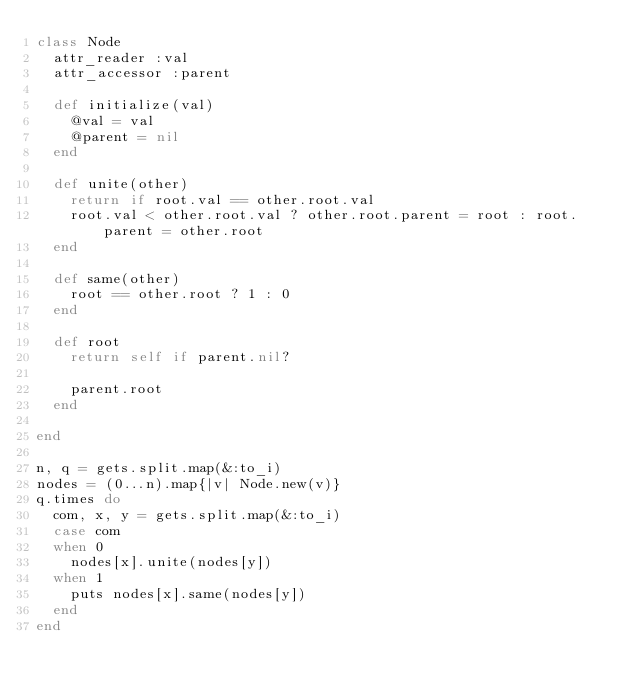<code> <loc_0><loc_0><loc_500><loc_500><_Ruby_>class Node
  attr_reader :val
  attr_accessor :parent

  def initialize(val)
    @val = val
    @parent = nil
  end

  def unite(other)
    return if root.val == other.root.val
    root.val < other.root.val ? other.root.parent = root : root.parent = other.root
  end

  def same(other)
    root == other.root ? 1 : 0
  end

  def root
    return self if parent.nil?

    parent.root
  end
 
end

n, q = gets.split.map(&:to_i)
nodes = (0...n).map{|v| Node.new(v)}
q.times do
  com, x, y = gets.split.map(&:to_i)
  case com
  when 0
    nodes[x].unite(nodes[y])
  when 1
    puts nodes[x].same(nodes[y])
  end
end</code> 